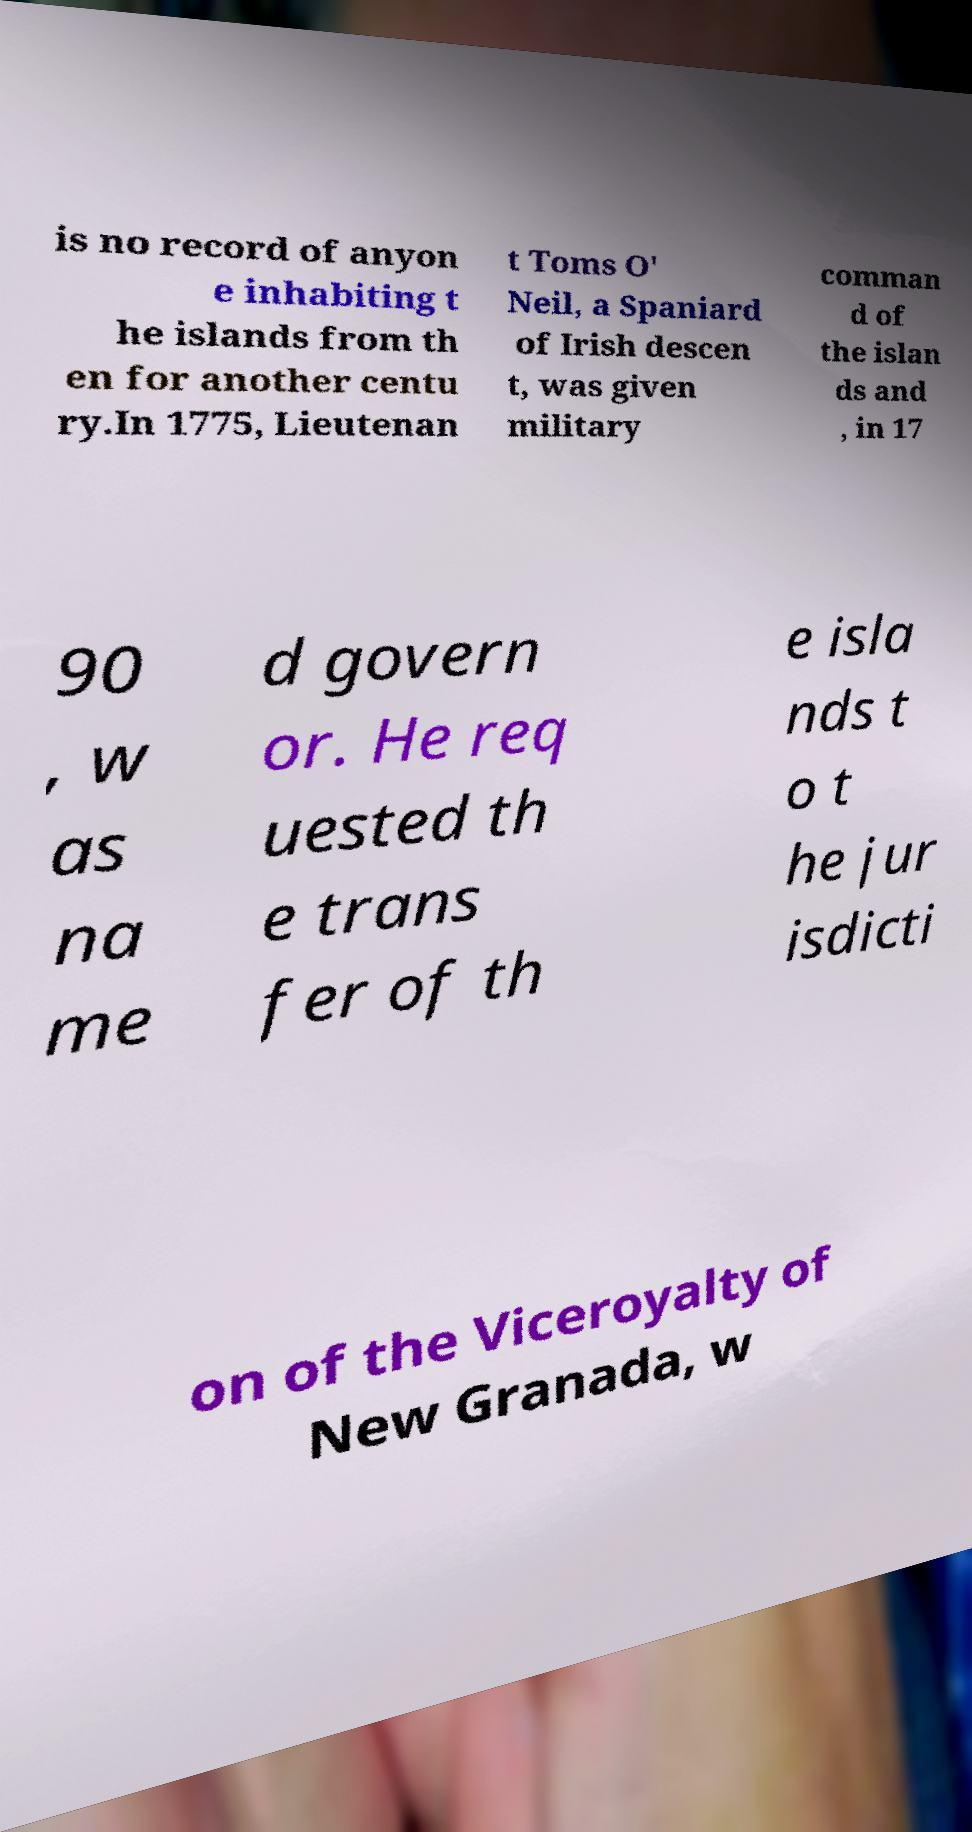Can you accurately transcribe the text from the provided image for me? is no record of anyon e inhabiting t he islands from th en for another centu ry.In 1775, Lieutenan t Toms O' Neil, a Spaniard of Irish descen t, was given military comman d of the islan ds and , in 17 90 , w as na me d govern or. He req uested th e trans fer of th e isla nds t o t he jur isdicti on of the Viceroyalty of New Granada, w 